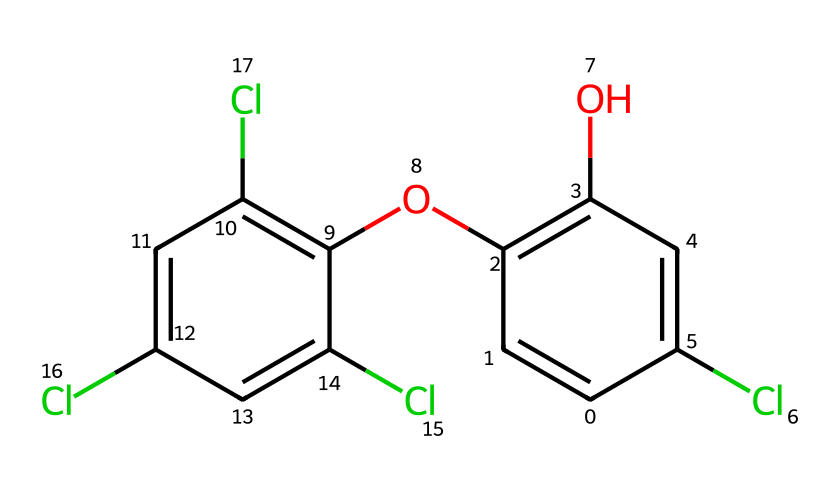How many chlorine (Cl) atoms are present in triclosan? By examining the SMILES representation, we see the presence of multiple "Cl" in the string. Counting the "Cl" tokens indicates there are four chlorine atoms in total.
Answer: four What type of functional group is indicated by the "O" in the structure? In the SMILES representation, "O" indicates the presence of an alcohol functional group and an ether group. The "O" is part of the hydroxyl group (-OH) in the alcohol, showing a link to the aromatic ring.
Answer: alcohol and ether What is the total number of carbon (C) atoms in triclosan? The SMILES representation has several "C" in the structure, upon counting, we find there are 12 carbon atoms present in total.
Answer: twelve What is the general classification of triclosan based on its chemical structure? The presence of multiple carbon rings and halogen substitutions (chlorines) suggests that triclosan is a chlorinated aromatic compound, typically classified as a biocide or antimicrobial.
Answer: biocide How many rings are present in the molecular structure of triclosan? The SMILES representation indicates two distinct benzene rings in the structure. They are indicated by the "C=C" sequences that form the rings. Count confirms there are two rings.
Answer: two What type of bonding is primarily present in the aromatic regions of triclosan? The aromatic regions in the chemical structure are characterized by alternating double bonds, typically indicating resonance and contributing to stability; the connections within the rings indicate this.
Answer: resonance 